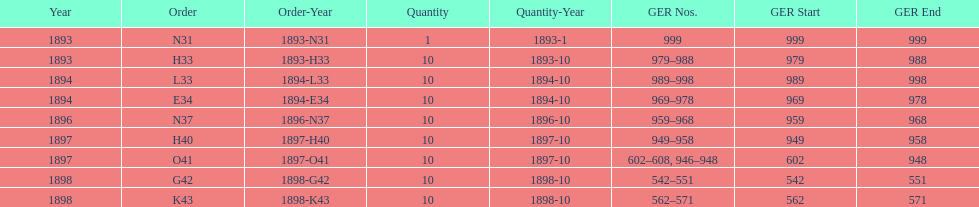How many years are listed? 5. 